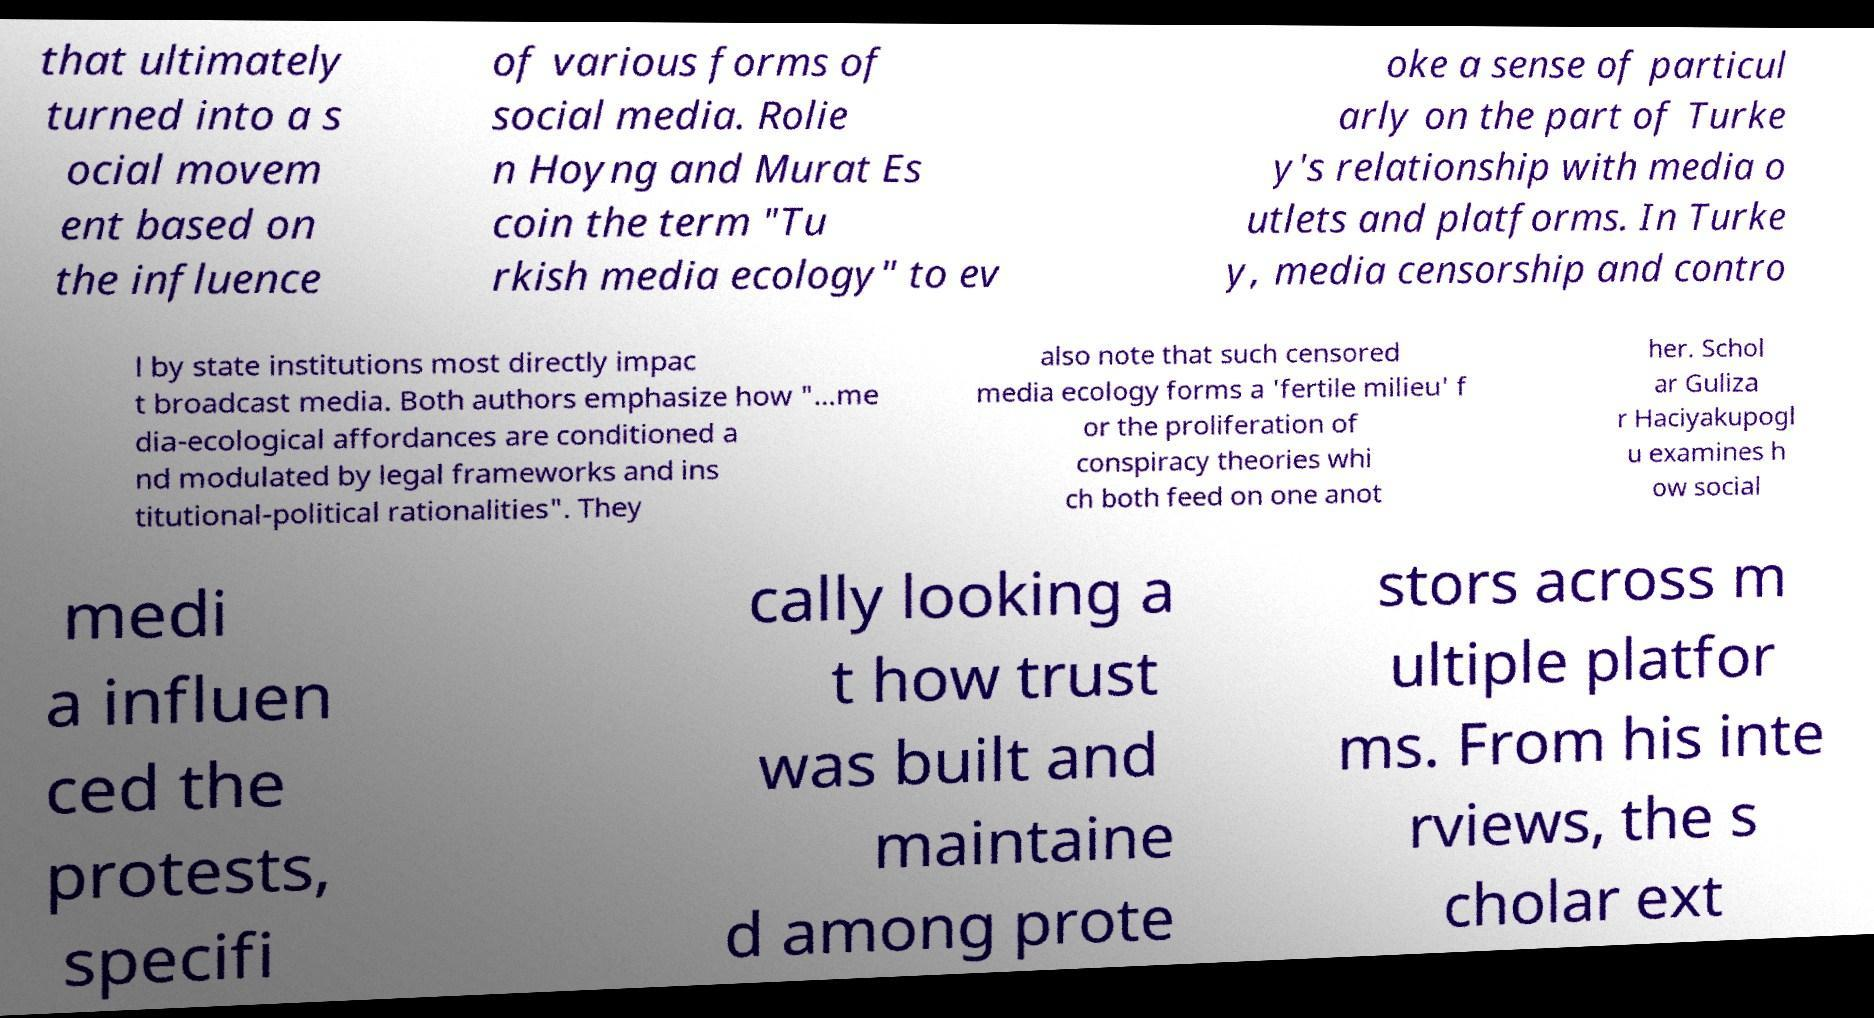Can you accurately transcribe the text from the provided image for me? that ultimately turned into a s ocial movem ent based on the influence of various forms of social media. Rolie n Hoyng and Murat Es coin the term "Tu rkish media ecology" to ev oke a sense of particul arly on the part of Turke y's relationship with media o utlets and platforms. In Turke y, media censorship and contro l by state institutions most directly impac t broadcast media. Both authors emphasize how "…me dia-ecological affordances are conditioned a nd modulated by legal frameworks and ins titutional-political rationalities". They also note that such censored media ecology forms a 'fertile milieu' f or the proliferation of conspiracy theories whi ch both feed on one anot her. Schol ar Guliza r Haciyakupogl u examines h ow social medi a influen ced the protests, specifi cally looking a t how trust was built and maintaine d among prote stors across m ultiple platfor ms. From his inte rviews, the s cholar ext 